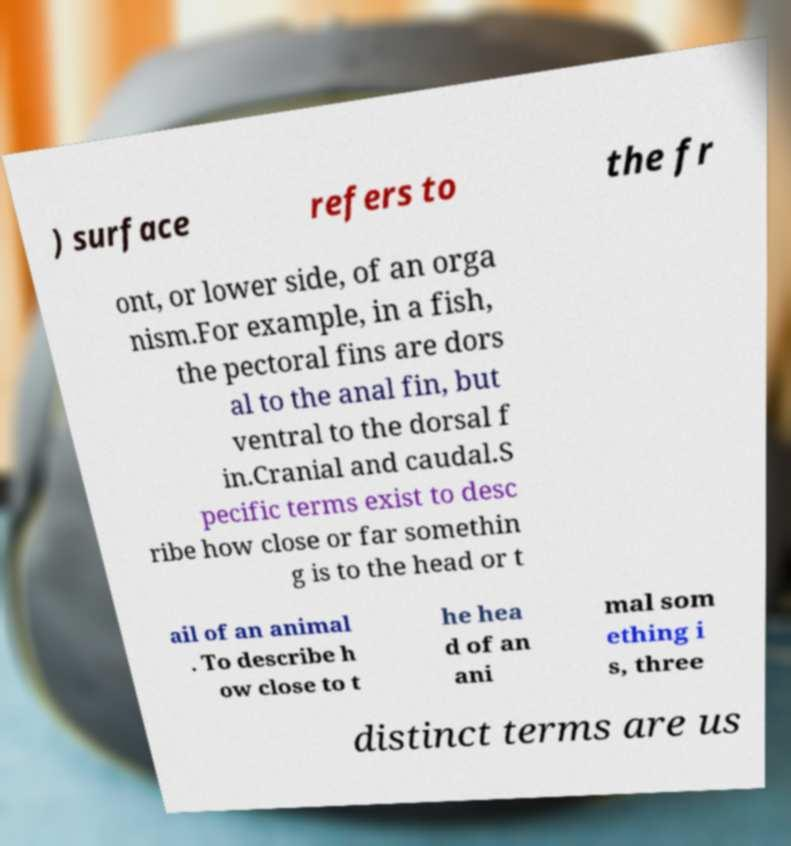Could you assist in decoding the text presented in this image and type it out clearly? ) surface refers to the fr ont, or lower side, of an orga nism.For example, in a fish, the pectoral fins are dors al to the anal fin, but ventral to the dorsal f in.Cranial and caudal.S pecific terms exist to desc ribe how close or far somethin g is to the head or t ail of an animal . To describe h ow close to t he hea d of an ani mal som ething i s, three distinct terms are us 